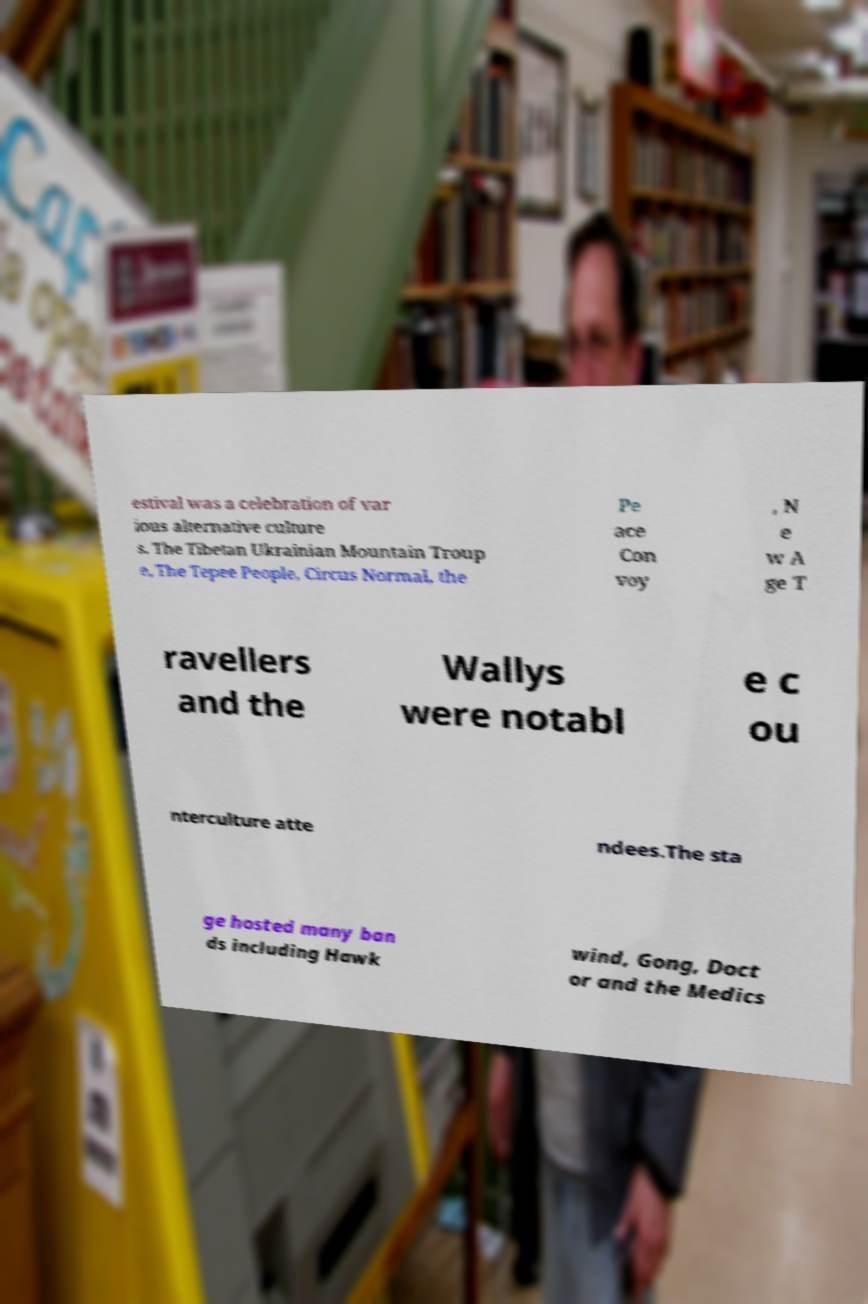Please read and relay the text visible in this image. What does it say? estival was a celebration of var ious alternative culture s. The Tibetan Ukrainian Mountain Troup e, The Tepee People, Circus Normal, the Pe ace Con voy , N e w A ge T ravellers and the Wallys were notabl e c ou nterculture atte ndees.The sta ge hosted many ban ds including Hawk wind, Gong, Doct or and the Medics 